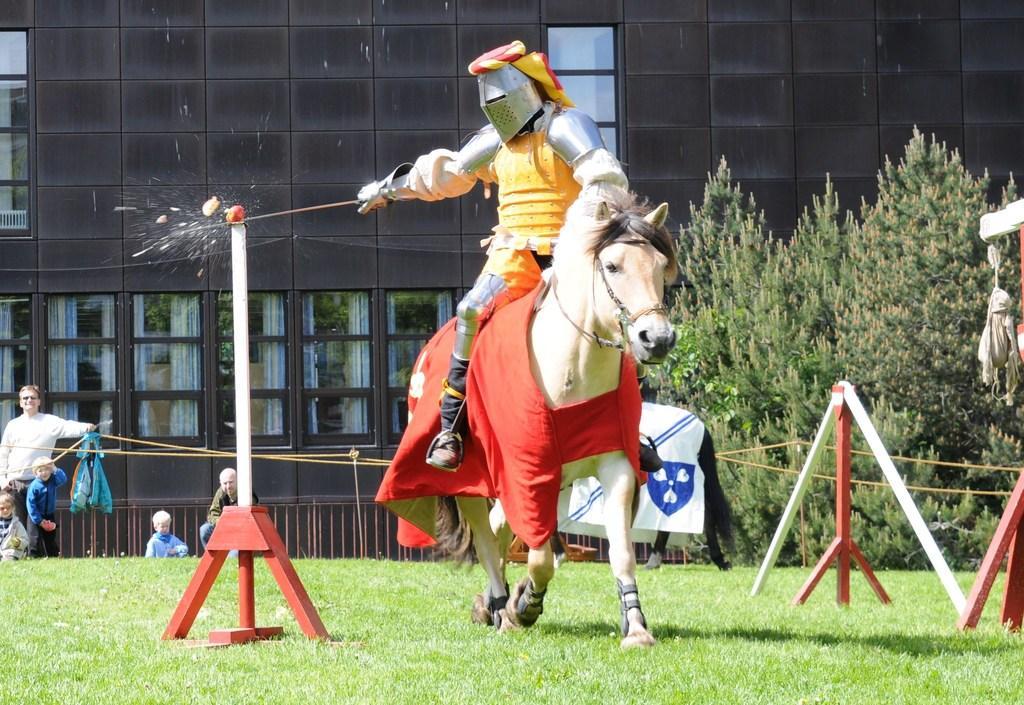In one or two sentences, can you explain what this image depicts? Here we can see that a horse on the grass, and a person sitting on it and holding some object in the hands, and at back their is the building, and here are the trees, and here is the rope. 